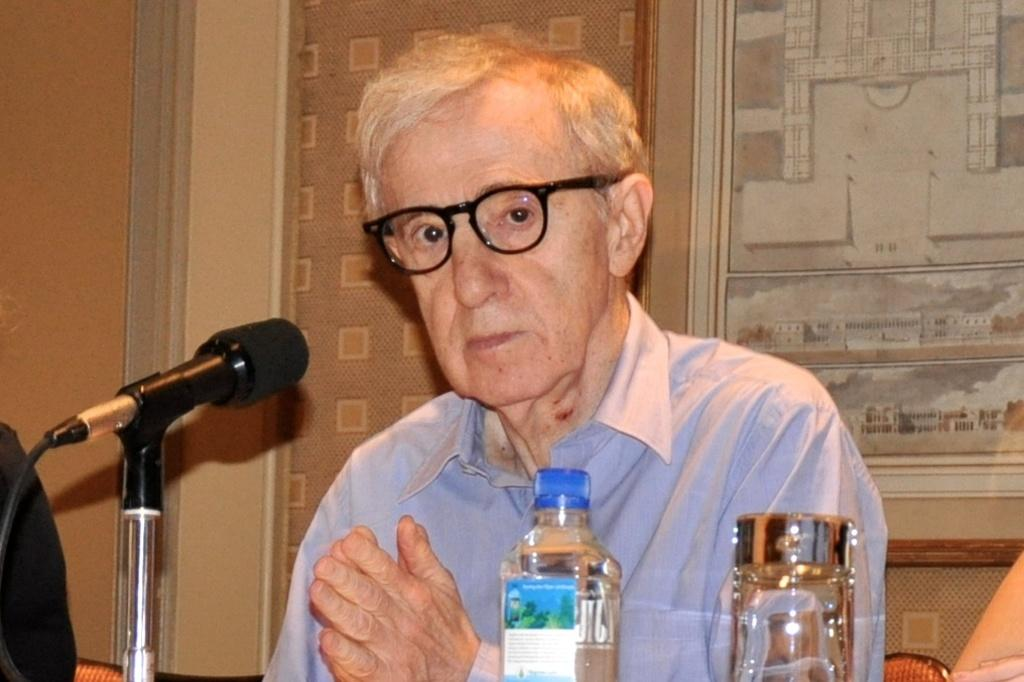What is the main setting of the image? There is a room in the image. What is the person in the room doing? The person is sitting on a chair in the room. What can be seen on the person's face? The person is wearing spectacles. What furniture is present in the room? There is a table in the room. What items are on the table? There is a bottle and a glass on the table. What can be seen in the background of the room? In the background of the room, there is a wall and a cupboard. How many horses are visible in the room? There are no horses present in the room; the image only shows a person sitting on a chair in a room with a table, a bottle, and a glass. What type of pail is being used by the person in the image? There is no pail present in the image; the person is simply sitting on a chair with spectacles on their face. 